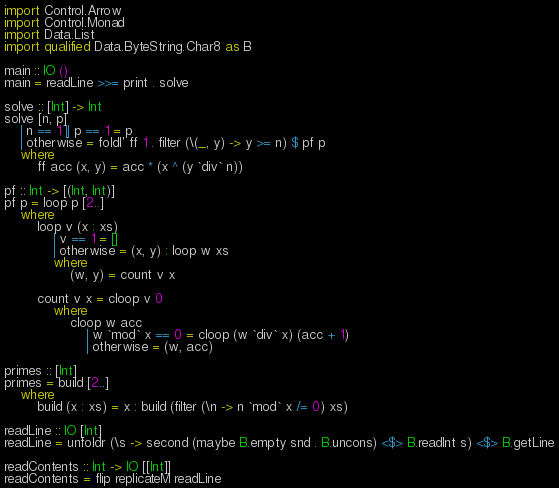<code> <loc_0><loc_0><loc_500><loc_500><_Haskell_>import Control.Arrow
import Control.Monad
import Data.List
import qualified Data.ByteString.Char8 as B

main :: IO ()
main = readLine >>= print . solve 

solve :: [Int] -> Int 
solve [n, p]
    | n == 1 || p == 1 = p
    | otherwise = foldl' ff 1 . filter (\(_, y) -> y >= n) $ pf p
    where
        ff acc (x, y) = acc * (x ^ (y `div` n))

pf :: Int -> [(Int, Int)]
pf p = loop p [2..]
    where
        loop v (x : xs)
            | v == 1 = []
            | otherwise = (x, y) : loop w xs 
            where
                (w, y) = count v x

        count v x = cloop v 0
            where
                cloop w acc 
                    | w `mod` x == 0 = cloop (w `div` x) (acc + 1)
                    | otherwise = (w, acc)

primes :: [Int]
primes = build [2..]
    where
        build (x : xs) = x : build (filter (\n -> n `mod` x /= 0) xs)

readLine :: IO [Int]
readLine = unfoldr (\s -> second (maybe B.empty snd . B.uncons) <$> B.readInt s) <$> B.getLine

readContents :: Int -> IO [[Int]]
readContents = flip replicateM readLine</code> 